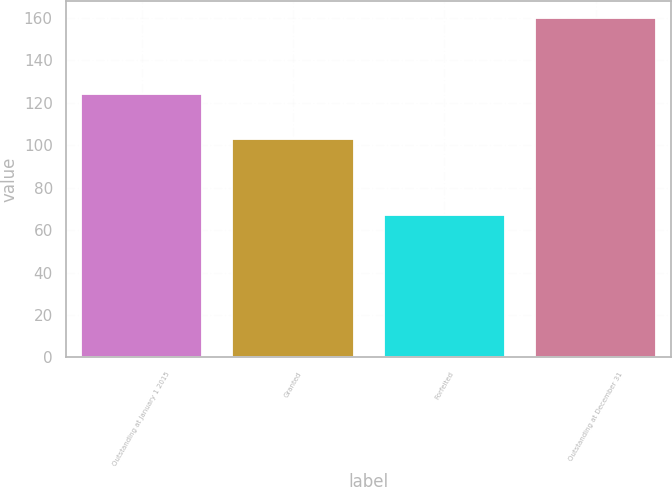Convert chart to OTSL. <chart><loc_0><loc_0><loc_500><loc_500><bar_chart><fcel>Outstanding at January 1 2015<fcel>Granted<fcel>Forfeited<fcel>Outstanding at December 31<nl><fcel>124<fcel>103<fcel>67<fcel>160<nl></chart> 